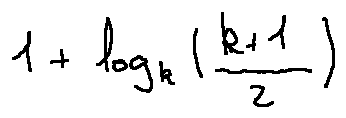<formula> <loc_0><loc_0><loc_500><loc_500>1 + \log _ { k } ( \frac { k + 1 } { 2 } )</formula> 